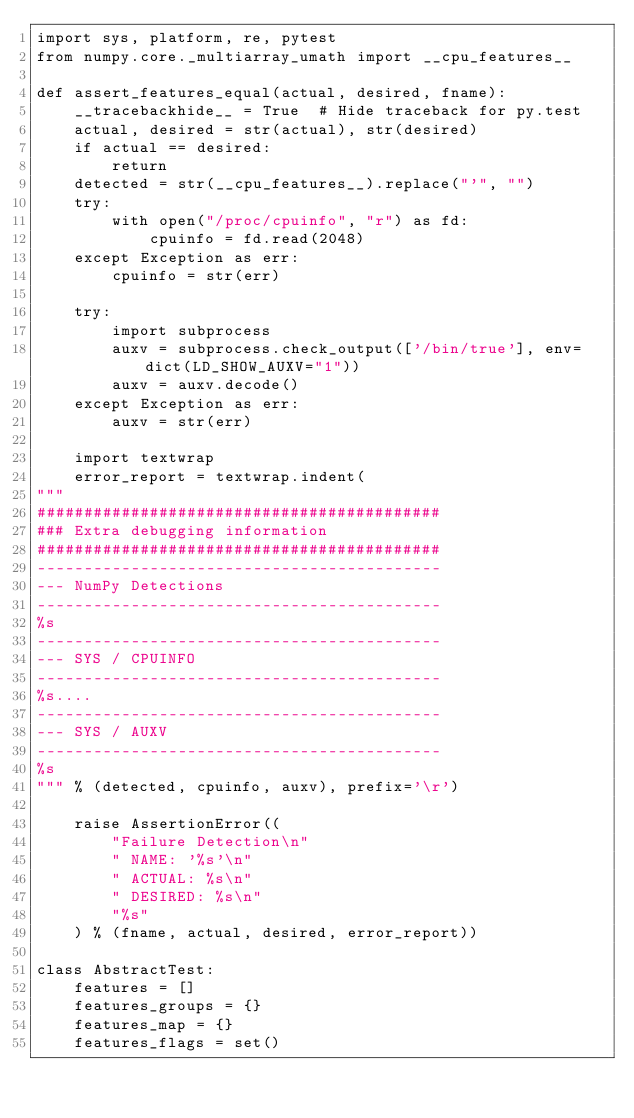<code> <loc_0><loc_0><loc_500><loc_500><_Python_>import sys, platform, re, pytest
from numpy.core._multiarray_umath import __cpu_features__

def assert_features_equal(actual, desired, fname):
    __tracebackhide__ = True  # Hide traceback for py.test
    actual, desired = str(actual), str(desired)
    if actual == desired:
        return
    detected = str(__cpu_features__).replace("'", "")
    try:
        with open("/proc/cpuinfo", "r") as fd:
            cpuinfo = fd.read(2048)
    except Exception as err:
        cpuinfo = str(err)

    try:
        import subprocess
        auxv = subprocess.check_output(['/bin/true'], env=dict(LD_SHOW_AUXV="1"))
        auxv = auxv.decode()
    except Exception as err:
        auxv = str(err)

    import textwrap
    error_report = textwrap.indent(
"""
###########################################
### Extra debugging information
###########################################
-------------------------------------------
--- NumPy Detections
-------------------------------------------
%s
-------------------------------------------
--- SYS / CPUINFO
-------------------------------------------
%s....
-------------------------------------------
--- SYS / AUXV
-------------------------------------------
%s
""" % (detected, cpuinfo, auxv), prefix='\r')

    raise AssertionError((
        "Failure Detection\n"
        " NAME: '%s'\n"
        " ACTUAL: %s\n"
        " DESIRED: %s\n"
        "%s"
    ) % (fname, actual, desired, error_report))

class AbstractTest:
    features = []
    features_groups = {}
    features_map = {}
    features_flags = set()
</code> 